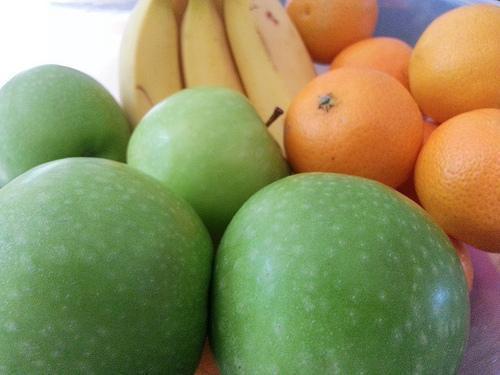How many different fruits are there?
Give a very brief answer. 3. How many apples are there?
Give a very brief answer. 4. 